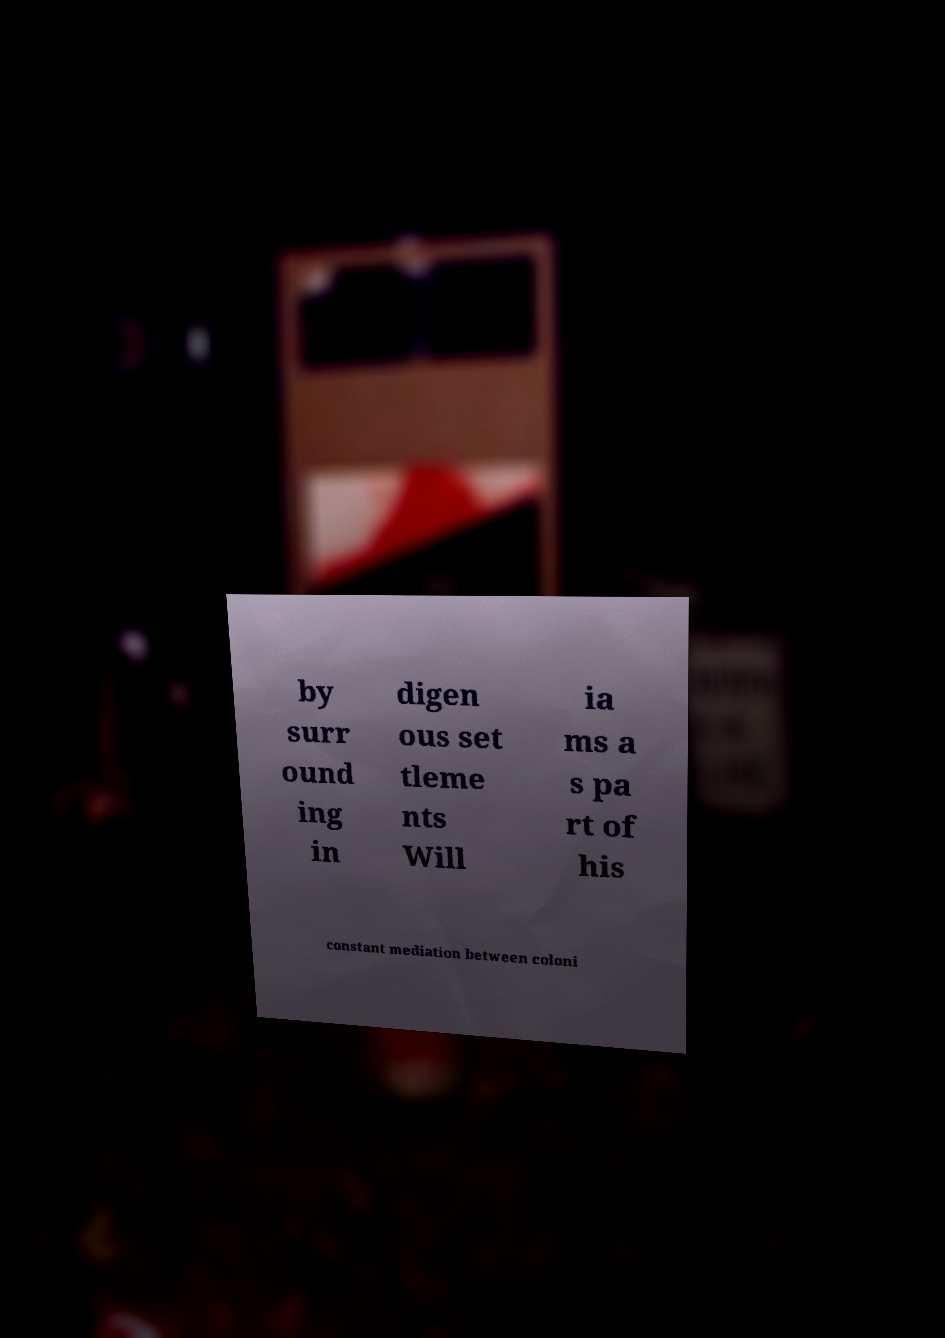For documentation purposes, I need the text within this image transcribed. Could you provide that? by surr ound ing in digen ous set tleme nts Will ia ms a s pa rt of his constant mediation between coloni 